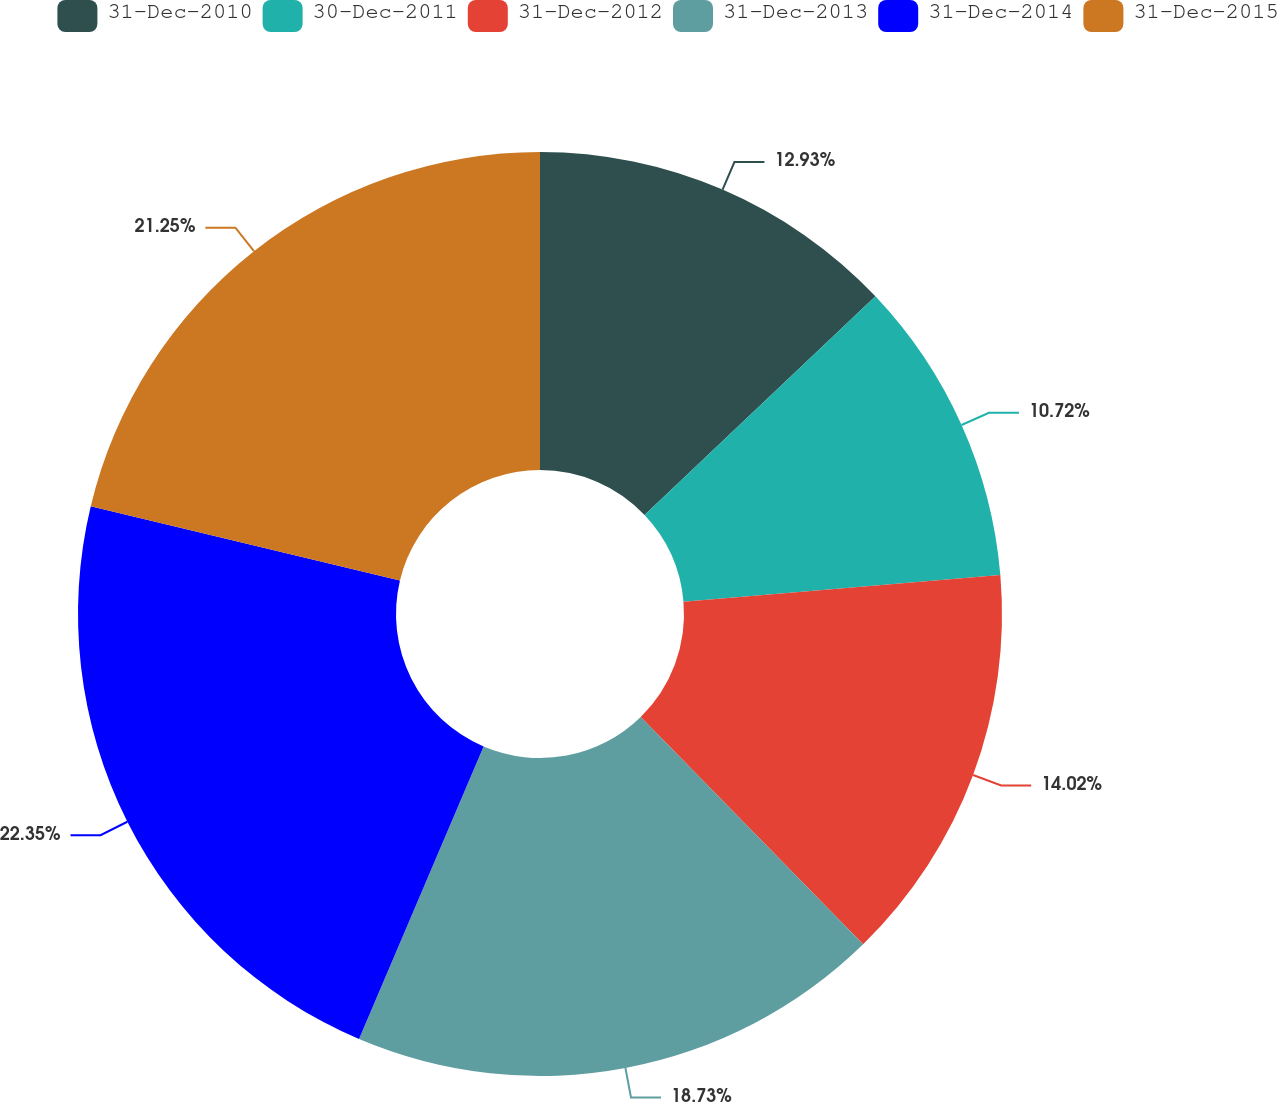<chart> <loc_0><loc_0><loc_500><loc_500><pie_chart><fcel>31-Dec-2010<fcel>30-Dec-2011<fcel>31-Dec-2012<fcel>31-Dec-2013<fcel>31-Dec-2014<fcel>31-Dec-2015<nl><fcel>12.93%<fcel>10.72%<fcel>14.02%<fcel>18.73%<fcel>22.34%<fcel>21.25%<nl></chart> 